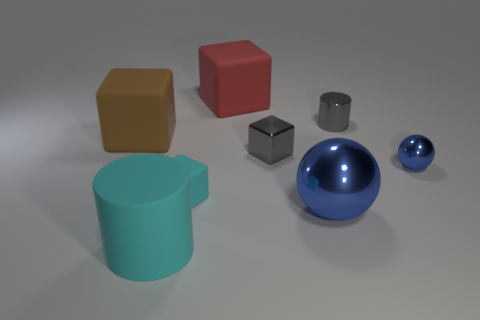There is a gray object that is the same shape as the big red object; what is its material?
Provide a succinct answer. Metal. How many red objects have the same size as the gray metal cylinder?
Provide a short and direct response. 0. There is a small metallic object that is in front of the big brown thing and right of the large blue object; what color is it?
Your answer should be compact. Blue. Is the number of small blue objects less than the number of tiny purple rubber objects?
Make the answer very short. No. There is a large shiny thing; is it the same color as the shiny sphere to the right of the small gray shiny cylinder?
Offer a terse response. Yes. Are there the same number of cyan matte cubes on the right side of the tiny cyan cube and large rubber cubes that are to the left of the big cylinder?
Give a very brief answer. No. How many metal things have the same shape as the large cyan matte thing?
Ensure brevity in your answer.  1. Are there any large blue balls?
Give a very brief answer. Yes. Does the big cylinder have the same material as the cylinder that is on the right side of the big shiny sphere?
Keep it short and to the point. No. There is a brown thing that is the same size as the cyan rubber cylinder; what is its material?
Your answer should be very brief. Rubber. 